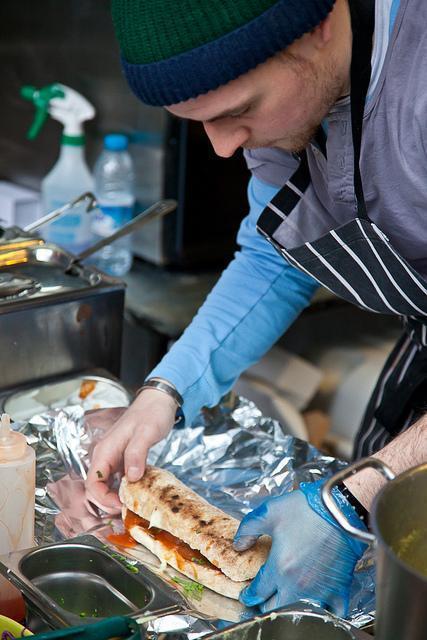How many bottles can be seen?
Give a very brief answer. 2. How many zebras are in the picture?
Give a very brief answer. 0. 